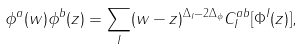Convert formula to latex. <formula><loc_0><loc_0><loc_500><loc_500>\phi ^ { a } ( w ) \phi ^ { b } ( z ) = { \sum _ { I } } ( w - z ) ^ { \Delta _ { I } - 2 \Delta _ { \phi } } C _ { I } ^ { a b } [ \Phi ^ { I } ( z ) ] ,</formula> 